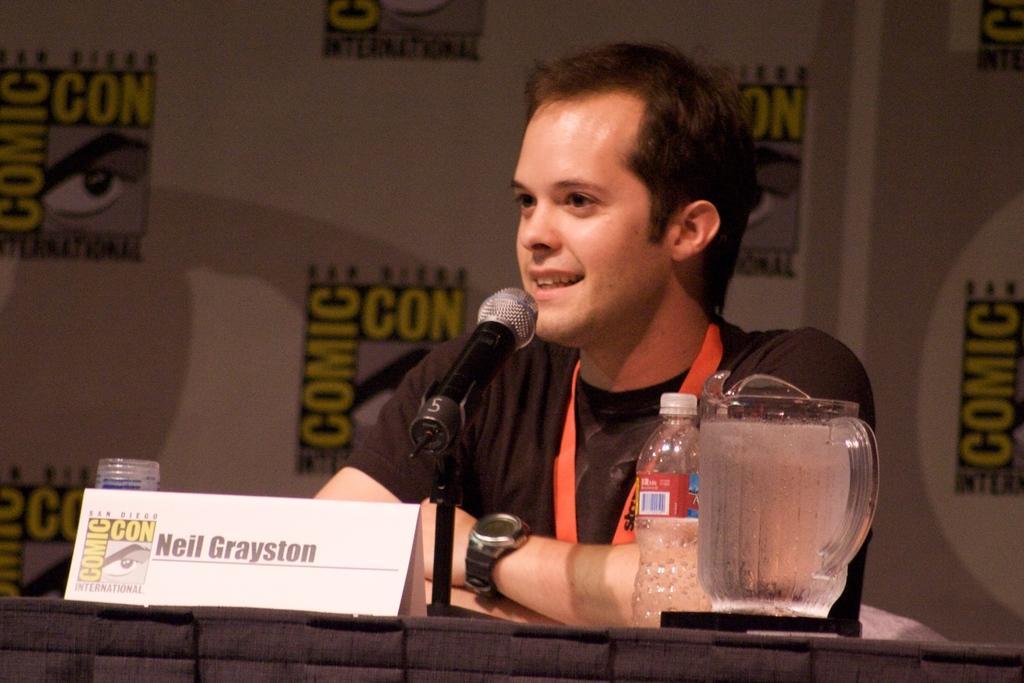In one or two sentences, can you explain what this image depicts? In the middle of the image we can see a man, he is seated, in front of him we can find a microphone, bottle, jug, name board and other things on the table. 